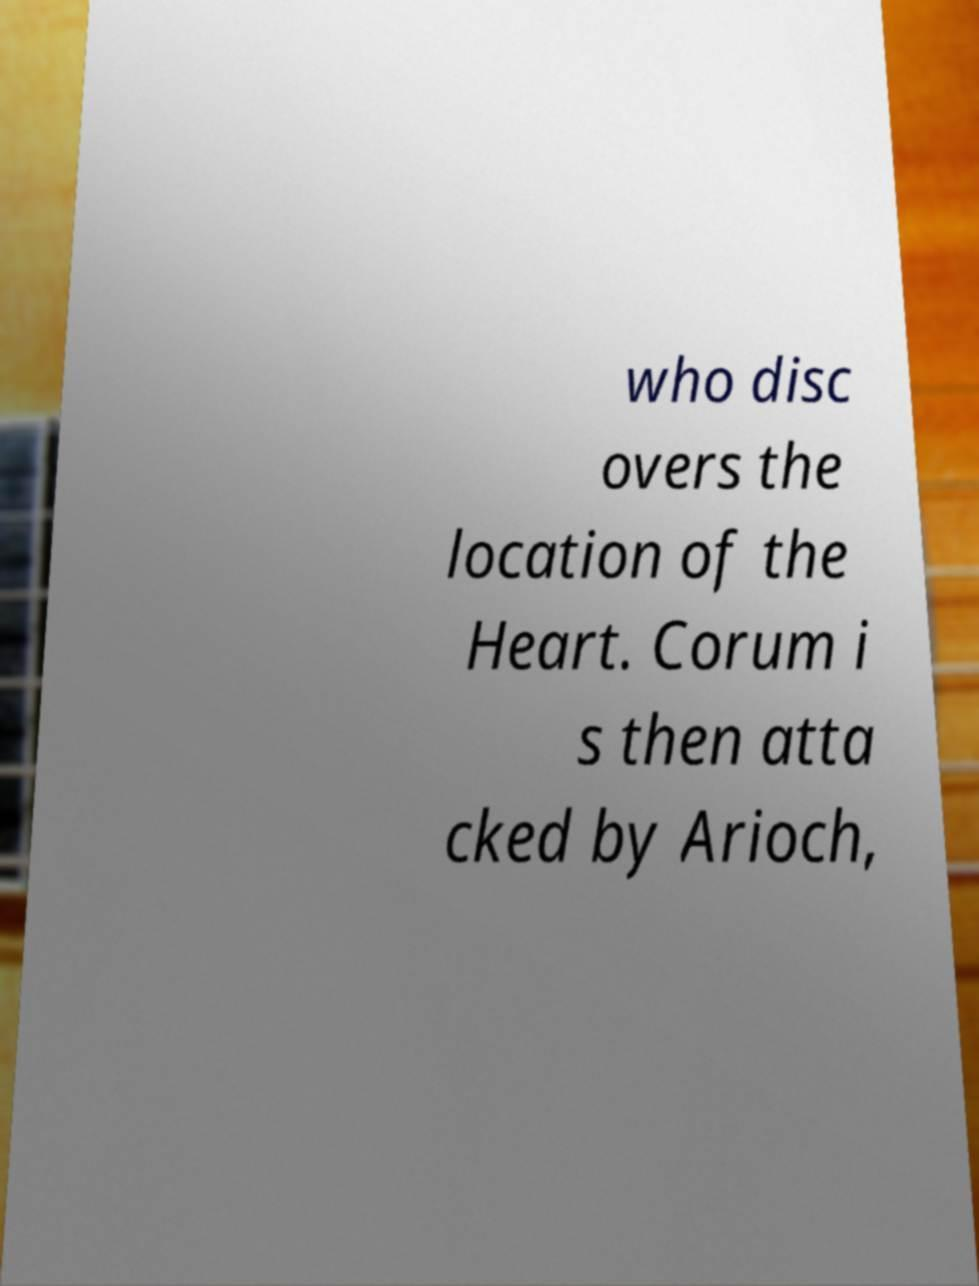Please identify and transcribe the text found in this image. who disc overs the location of the Heart. Corum i s then atta cked by Arioch, 